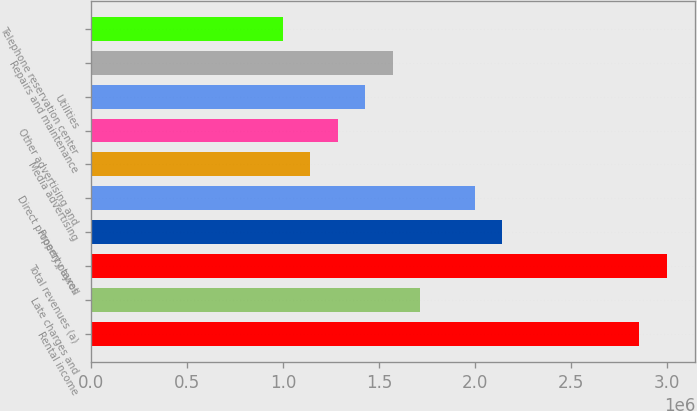<chart> <loc_0><loc_0><loc_500><loc_500><bar_chart><fcel>Rental income<fcel>Late charges and<fcel>Total revenues (a)<fcel>Property taxes<fcel>Direct property payroll<fcel>Media advertising<fcel>Other advertising and<fcel>Utilities<fcel>Repairs and maintenance<fcel>Telephone reservation center<nl><fcel>2.85542e+06<fcel>1.71326e+06<fcel>2.99819e+06<fcel>2.14157e+06<fcel>1.9988e+06<fcel>1.14218e+06<fcel>1.28495e+06<fcel>1.42772e+06<fcel>1.57049e+06<fcel>999405<nl></chart> 